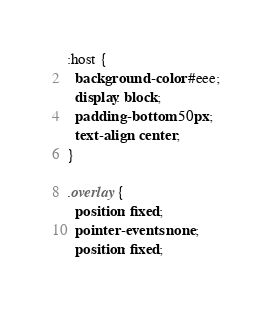Convert code to text. <code><loc_0><loc_0><loc_500><loc_500><_CSS_>:host {
  background-color: #eee;
  display: block;
  padding-bottom: 50px;
  text-align: center;
}

.overlay {
  position: fixed;
  pointer-events: none;
  position: fixed;</code> 